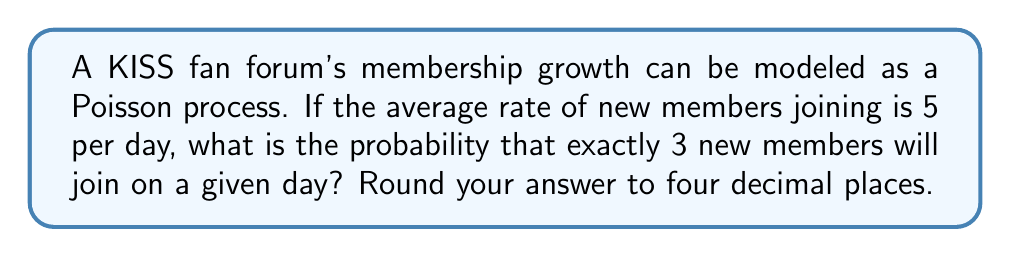Solve this math problem. To solve this problem, we'll use the Poisson distribution formula:

$$P(X = k) = \frac{e^{-\lambda}\lambda^k}{k!}$$

Where:
$\lambda$ = average rate of events (new members per day)
$k$ = number of events we're interested in (new members on a given day)
$e$ = Euler's number (approximately 2.71828)

Given:
$\lambda = 5$ (average of 5 new members per day)
$k = 3$ (we want exactly 3 new members)

Let's substitute these values into the formula:

$$P(X = 3) = \frac{e^{-5}5^3}{3!}$$

Step 1: Calculate $e^{-5}$
$$e^{-5} \approx 0.006738$$

Step 2: Calculate $5^3$
$$5^3 = 125$$

Step 3: Calculate $3!$
$$3! = 3 \times 2 \times 1 = 6$$

Step 4: Substitute these values into the formula
$$P(X = 3) = \frac{0.006738 \times 125}{6}$$

Step 5: Perform the calculation
$$P(X = 3) = \frac{0.84225}{6} = 0.140375$$

Step 6: Round to four decimal places
$$P(X = 3) \approx 0.1404$$

Therefore, the probability of exactly 3 new members joining the KISS fan forum on a given day is approximately 0.1404 or 14.04%.
Answer: 0.1404 